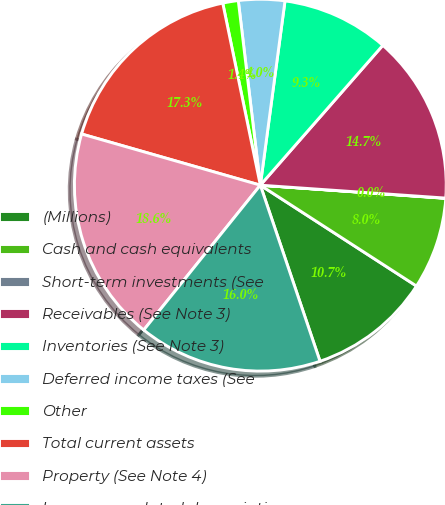Convert chart. <chart><loc_0><loc_0><loc_500><loc_500><pie_chart><fcel>(Millions)<fcel>Cash and cash equivalents<fcel>Short-term investments (See<fcel>Receivables (See Note 3)<fcel>Inventories (See Note 3)<fcel>Deferred income taxes (See<fcel>Other<fcel>Total current assets<fcel>Property (See Note 4)<fcel>Less accumulated depreciation<nl><fcel>10.67%<fcel>8.0%<fcel>0.02%<fcel>14.66%<fcel>9.33%<fcel>4.01%<fcel>1.35%<fcel>17.32%<fcel>18.65%<fcel>15.99%<nl></chart> 